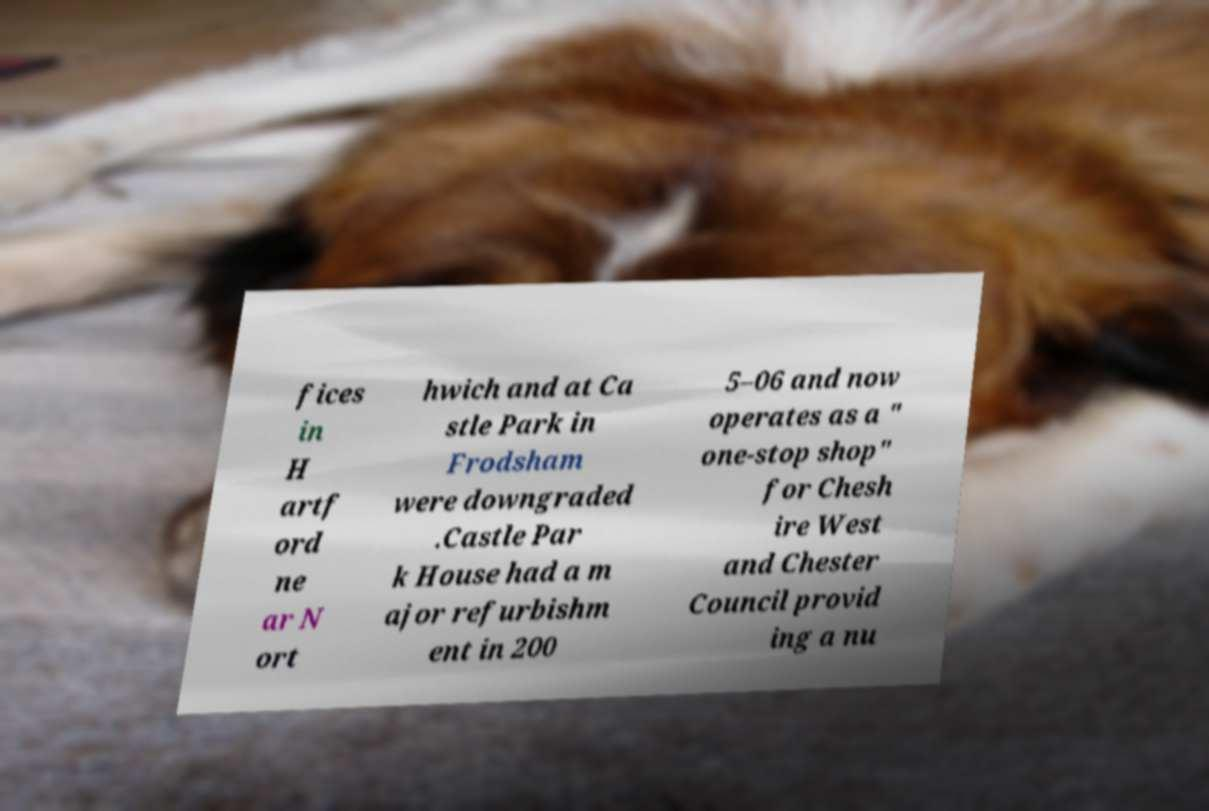Please read and relay the text visible in this image. What does it say? fices in H artf ord ne ar N ort hwich and at Ca stle Park in Frodsham were downgraded .Castle Par k House had a m ajor refurbishm ent in 200 5–06 and now operates as a " one-stop shop" for Chesh ire West and Chester Council provid ing a nu 